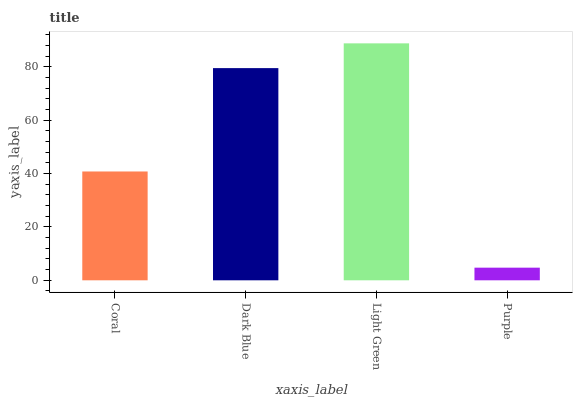Is Purple the minimum?
Answer yes or no. Yes. Is Light Green the maximum?
Answer yes or no. Yes. Is Dark Blue the minimum?
Answer yes or no. No. Is Dark Blue the maximum?
Answer yes or no. No. Is Dark Blue greater than Coral?
Answer yes or no. Yes. Is Coral less than Dark Blue?
Answer yes or no. Yes. Is Coral greater than Dark Blue?
Answer yes or no. No. Is Dark Blue less than Coral?
Answer yes or no. No. Is Dark Blue the high median?
Answer yes or no. Yes. Is Coral the low median?
Answer yes or no. Yes. Is Purple the high median?
Answer yes or no. No. Is Dark Blue the low median?
Answer yes or no. No. 